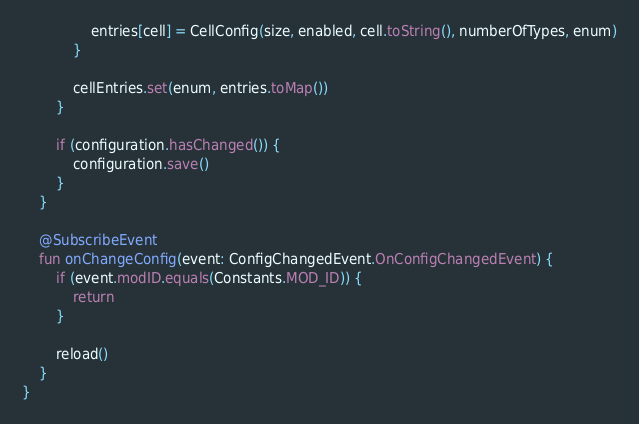<code> <loc_0><loc_0><loc_500><loc_500><_Kotlin_>
                entries[cell] = CellConfig(size, enabled, cell.toString(), numberOfTypes, enum)
            }

            cellEntries.set(enum, entries.toMap())
        }

        if (configuration.hasChanged()) {
            configuration.save()
        }
    }

    @SubscribeEvent
    fun onChangeConfig(event: ConfigChangedEvent.OnConfigChangedEvent) {
        if (event.modID.equals(Constants.MOD_ID)) {
            return
        }

        reload()
    }
}</code> 